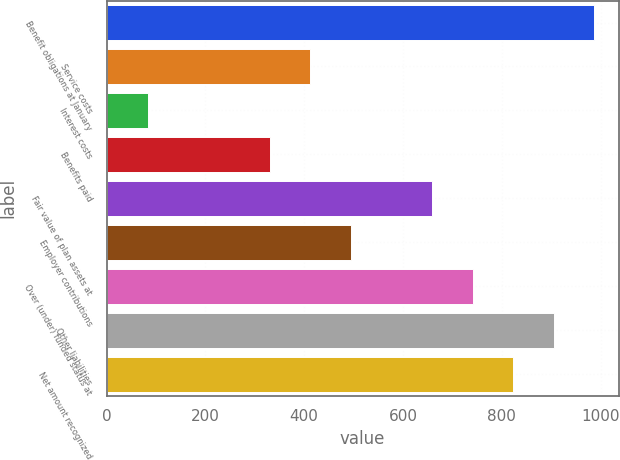<chart> <loc_0><loc_0><loc_500><loc_500><bar_chart><fcel>Benefit obligations at January<fcel>Service costs<fcel>Interest costs<fcel>Benefits paid<fcel>Fair value of plan assets at<fcel>Employer contributions<fcel>Over (under) funded status at<fcel>Other liabilities<fcel>Net amount recognized<nl><fcel>987.2<fcel>412.5<fcel>84.1<fcel>330.4<fcel>658.8<fcel>494.6<fcel>740.9<fcel>905.1<fcel>823<nl></chart> 